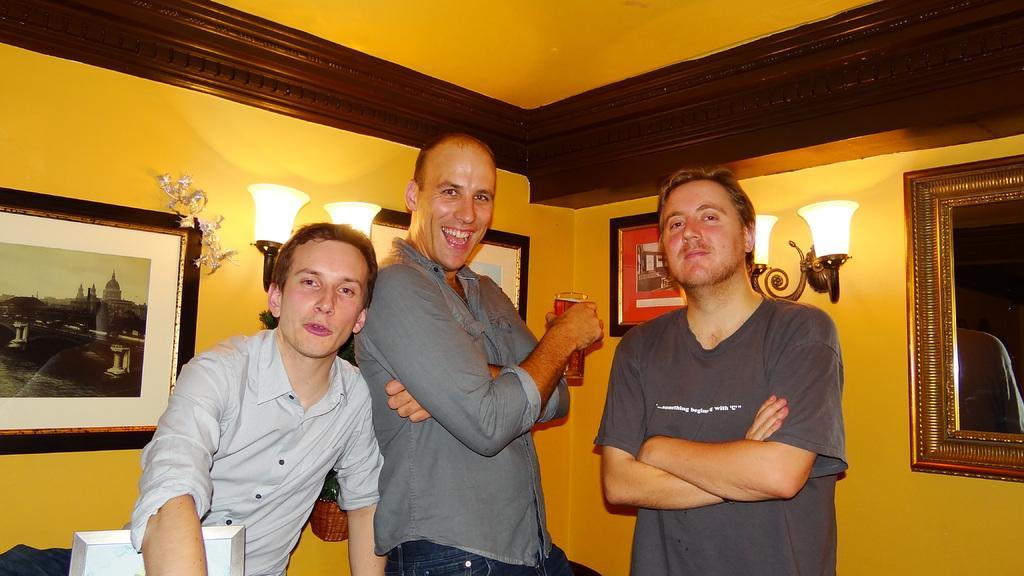Please provide a concise description of this image. This picture shows a few people Standing and we see a man holding a glass in his hand and we see few photo frames on the wall and few lights 